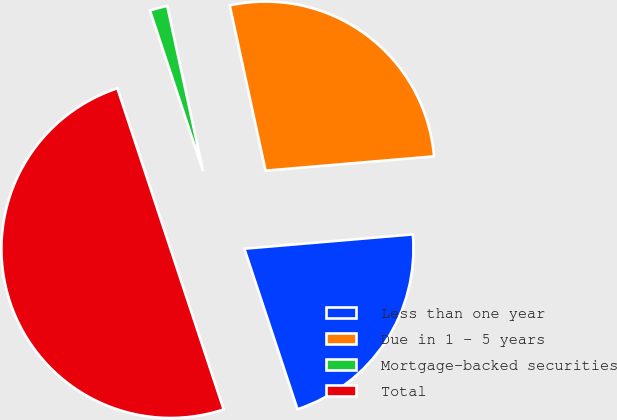Convert chart to OTSL. <chart><loc_0><loc_0><loc_500><loc_500><pie_chart><fcel>Less than one year<fcel>Due in 1 - 5 years<fcel>Mortgage-backed securities<fcel>Total<nl><fcel>21.26%<fcel>27.05%<fcel>1.69%<fcel>50.0%<nl></chart> 